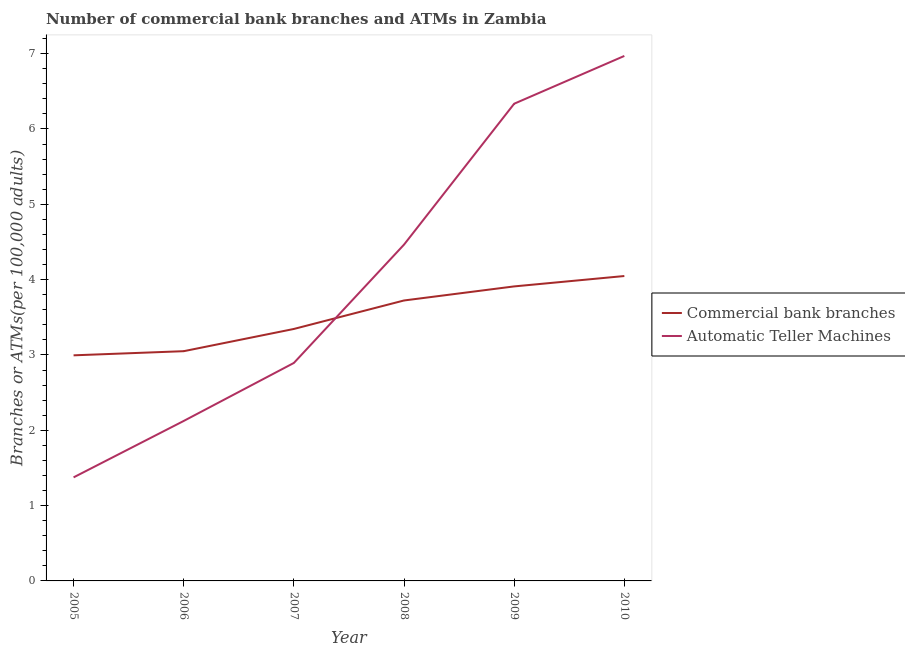Does the line corresponding to number of atms intersect with the line corresponding to number of commercal bank branches?
Keep it short and to the point. Yes. Is the number of lines equal to the number of legend labels?
Provide a succinct answer. Yes. What is the number of commercal bank branches in 2009?
Your response must be concise. 3.91. Across all years, what is the maximum number of commercal bank branches?
Offer a very short reply. 4.05. Across all years, what is the minimum number of atms?
Provide a short and direct response. 1.37. What is the total number of atms in the graph?
Your response must be concise. 24.16. What is the difference between the number of atms in 2005 and that in 2007?
Make the answer very short. -1.52. What is the difference between the number of commercal bank branches in 2007 and the number of atms in 2008?
Offer a very short reply. -1.12. What is the average number of atms per year?
Offer a very short reply. 4.03. In the year 2006, what is the difference between the number of commercal bank branches and number of atms?
Your response must be concise. 0.93. In how many years, is the number of atms greater than 2.2?
Provide a short and direct response. 4. What is the ratio of the number of atms in 2007 to that in 2010?
Keep it short and to the point. 0.42. What is the difference between the highest and the second highest number of commercal bank branches?
Your response must be concise. 0.14. What is the difference between the highest and the lowest number of atms?
Give a very brief answer. 5.59. Is the number of atms strictly less than the number of commercal bank branches over the years?
Offer a very short reply. No. How many years are there in the graph?
Your answer should be compact. 6. What is the difference between two consecutive major ticks on the Y-axis?
Provide a short and direct response. 1. Are the values on the major ticks of Y-axis written in scientific E-notation?
Make the answer very short. No. Does the graph contain any zero values?
Ensure brevity in your answer.  No. Does the graph contain grids?
Ensure brevity in your answer.  No. Where does the legend appear in the graph?
Make the answer very short. Center right. What is the title of the graph?
Offer a very short reply. Number of commercial bank branches and ATMs in Zambia. What is the label or title of the Y-axis?
Keep it short and to the point. Branches or ATMs(per 100,0 adults). What is the Branches or ATMs(per 100,000 adults) of Commercial bank branches in 2005?
Provide a succinct answer. 2.99. What is the Branches or ATMs(per 100,000 adults) of Automatic Teller Machines in 2005?
Your answer should be compact. 1.37. What is the Branches or ATMs(per 100,000 adults) in Commercial bank branches in 2006?
Provide a succinct answer. 3.05. What is the Branches or ATMs(per 100,000 adults) of Automatic Teller Machines in 2006?
Your answer should be very brief. 2.12. What is the Branches or ATMs(per 100,000 adults) of Commercial bank branches in 2007?
Provide a short and direct response. 3.34. What is the Branches or ATMs(per 100,000 adults) in Automatic Teller Machines in 2007?
Keep it short and to the point. 2.89. What is the Branches or ATMs(per 100,000 adults) of Commercial bank branches in 2008?
Provide a succinct answer. 3.72. What is the Branches or ATMs(per 100,000 adults) in Automatic Teller Machines in 2008?
Provide a short and direct response. 4.46. What is the Branches or ATMs(per 100,000 adults) of Commercial bank branches in 2009?
Your answer should be compact. 3.91. What is the Branches or ATMs(per 100,000 adults) of Automatic Teller Machines in 2009?
Provide a succinct answer. 6.33. What is the Branches or ATMs(per 100,000 adults) in Commercial bank branches in 2010?
Your response must be concise. 4.05. What is the Branches or ATMs(per 100,000 adults) in Automatic Teller Machines in 2010?
Your answer should be compact. 6.97. Across all years, what is the maximum Branches or ATMs(per 100,000 adults) of Commercial bank branches?
Your answer should be very brief. 4.05. Across all years, what is the maximum Branches or ATMs(per 100,000 adults) in Automatic Teller Machines?
Give a very brief answer. 6.97. Across all years, what is the minimum Branches or ATMs(per 100,000 adults) of Commercial bank branches?
Provide a succinct answer. 2.99. Across all years, what is the minimum Branches or ATMs(per 100,000 adults) of Automatic Teller Machines?
Provide a short and direct response. 1.37. What is the total Branches or ATMs(per 100,000 adults) in Commercial bank branches in the graph?
Make the answer very short. 21.07. What is the total Branches or ATMs(per 100,000 adults) of Automatic Teller Machines in the graph?
Your response must be concise. 24.16. What is the difference between the Branches or ATMs(per 100,000 adults) in Commercial bank branches in 2005 and that in 2006?
Provide a succinct answer. -0.06. What is the difference between the Branches or ATMs(per 100,000 adults) of Automatic Teller Machines in 2005 and that in 2006?
Your response must be concise. -0.75. What is the difference between the Branches or ATMs(per 100,000 adults) of Commercial bank branches in 2005 and that in 2007?
Make the answer very short. -0.35. What is the difference between the Branches or ATMs(per 100,000 adults) in Automatic Teller Machines in 2005 and that in 2007?
Provide a short and direct response. -1.52. What is the difference between the Branches or ATMs(per 100,000 adults) of Commercial bank branches in 2005 and that in 2008?
Offer a very short reply. -0.73. What is the difference between the Branches or ATMs(per 100,000 adults) of Automatic Teller Machines in 2005 and that in 2008?
Keep it short and to the point. -3.09. What is the difference between the Branches or ATMs(per 100,000 adults) of Commercial bank branches in 2005 and that in 2009?
Keep it short and to the point. -0.92. What is the difference between the Branches or ATMs(per 100,000 adults) in Automatic Teller Machines in 2005 and that in 2009?
Offer a very short reply. -4.96. What is the difference between the Branches or ATMs(per 100,000 adults) in Commercial bank branches in 2005 and that in 2010?
Keep it short and to the point. -1.05. What is the difference between the Branches or ATMs(per 100,000 adults) of Automatic Teller Machines in 2005 and that in 2010?
Provide a succinct answer. -5.59. What is the difference between the Branches or ATMs(per 100,000 adults) in Commercial bank branches in 2006 and that in 2007?
Your answer should be compact. -0.3. What is the difference between the Branches or ATMs(per 100,000 adults) in Automatic Teller Machines in 2006 and that in 2007?
Your answer should be very brief. -0.77. What is the difference between the Branches or ATMs(per 100,000 adults) in Commercial bank branches in 2006 and that in 2008?
Make the answer very short. -0.67. What is the difference between the Branches or ATMs(per 100,000 adults) in Automatic Teller Machines in 2006 and that in 2008?
Your answer should be compact. -2.34. What is the difference between the Branches or ATMs(per 100,000 adults) of Commercial bank branches in 2006 and that in 2009?
Offer a very short reply. -0.86. What is the difference between the Branches or ATMs(per 100,000 adults) in Automatic Teller Machines in 2006 and that in 2009?
Your answer should be very brief. -4.21. What is the difference between the Branches or ATMs(per 100,000 adults) of Commercial bank branches in 2006 and that in 2010?
Offer a terse response. -1. What is the difference between the Branches or ATMs(per 100,000 adults) of Automatic Teller Machines in 2006 and that in 2010?
Your response must be concise. -4.85. What is the difference between the Branches or ATMs(per 100,000 adults) of Commercial bank branches in 2007 and that in 2008?
Ensure brevity in your answer.  -0.38. What is the difference between the Branches or ATMs(per 100,000 adults) of Automatic Teller Machines in 2007 and that in 2008?
Offer a very short reply. -1.57. What is the difference between the Branches or ATMs(per 100,000 adults) in Commercial bank branches in 2007 and that in 2009?
Make the answer very short. -0.56. What is the difference between the Branches or ATMs(per 100,000 adults) of Automatic Teller Machines in 2007 and that in 2009?
Your answer should be very brief. -3.44. What is the difference between the Branches or ATMs(per 100,000 adults) of Commercial bank branches in 2007 and that in 2010?
Offer a terse response. -0.7. What is the difference between the Branches or ATMs(per 100,000 adults) of Automatic Teller Machines in 2007 and that in 2010?
Your answer should be very brief. -4.08. What is the difference between the Branches or ATMs(per 100,000 adults) in Commercial bank branches in 2008 and that in 2009?
Provide a succinct answer. -0.19. What is the difference between the Branches or ATMs(per 100,000 adults) in Automatic Teller Machines in 2008 and that in 2009?
Give a very brief answer. -1.87. What is the difference between the Branches or ATMs(per 100,000 adults) of Commercial bank branches in 2008 and that in 2010?
Provide a succinct answer. -0.32. What is the difference between the Branches or ATMs(per 100,000 adults) of Automatic Teller Machines in 2008 and that in 2010?
Give a very brief answer. -2.5. What is the difference between the Branches or ATMs(per 100,000 adults) of Commercial bank branches in 2009 and that in 2010?
Make the answer very short. -0.14. What is the difference between the Branches or ATMs(per 100,000 adults) of Automatic Teller Machines in 2009 and that in 2010?
Keep it short and to the point. -0.63. What is the difference between the Branches or ATMs(per 100,000 adults) in Commercial bank branches in 2005 and the Branches or ATMs(per 100,000 adults) in Automatic Teller Machines in 2006?
Offer a terse response. 0.87. What is the difference between the Branches or ATMs(per 100,000 adults) of Commercial bank branches in 2005 and the Branches or ATMs(per 100,000 adults) of Automatic Teller Machines in 2007?
Your answer should be very brief. 0.1. What is the difference between the Branches or ATMs(per 100,000 adults) in Commercial bank branches in 2005 and the Branches or ATMs(per 100,000 adults) in Automatic Teller Machines in 2008?
Your answer should be very brief. -1.47. What is the difference between the Branches or ATMs(per 100,000 adults) of Commercial bank branches in 2005 and the Branches or ATMs(per 100,000 adults) of Automatic Teller Machines in 2009?
Provide a short and direct response. -3.34. What is the difference between the Branches or ATMs(per 100,000 adults) of Commercial bank branches in 2005 and the Branches or ATMs(per 100,000 adults) of Automatic Teller Machines in 2010?
Provide a succinct answer. -3.97. What is the difference between the Branches or ATMs(per 100,000 adults) in Commercial bank branches in 2006 and the Branches or ATMs(per 100,000 adults) in Automatic Teller Machines in 2007?
Ensure brevity in your answer.  0.16. What is the difference between the Branches or ATMs(per 100,000 adults) in Commercial bank branches in 2006 and the Branches or ATMs(per 100,000 adults) in Automatic Teller Machines in 2008?
Your answer should be very brief. -1.41. What is the difference between the Branches or ATMs(per 100,000 adults) of Commercial bank branches in 2006 and the Branches or ATMs(per 100,000 adults) of Automatic Teller Machines in 2009?
Provide a short and direct response. -3.29. What is the difference between the Branches or ATMs(per 100,000 adults) of Commercial bank branches in 2006 and the Branches or ATMs(per 100,000 adults) of Automatic Teller Machines in 2010?
Your response must be concise. -3.92. What is the difference between the Branches or ATMs(per 100,000 adults) of Commercial bank branches in 2007 and the Branches or ATMs(per 100,000 adults) of Automatic Teller Machines in 2008?
Provide a short and direct response. -1.12. What is the difference between the Branches or ATMs(per 100,000 adults) in Commercial bank branches in 2007 and the Branches or ATMs(per 100,000 adults) in Automatic Teller Machines in 2009?
Your answer should be very brief. -2.99. What is the difference between the Branches or ATMs(per 100,000 adults) in Commercial bank branches in 2007 and the Branches or ATMs(per 100,000 adults) in Automatic Teller Machines in 2010?
Your response must be concise. -3.62. What is the difference between the Branches or ATMs(per 100,000 adults) in Commercial bank branches in 2008 and the Branches or ATMs(per 100,000 adults) in Automatic Teller Machines in 2009?
Provide a succinct answer. -2.61. What is the difference between the Branches or ATMs(per 100,000 adults) in Commercial bank branches in 2008 and the Branches or ATMs(per 100,000 adults) in Automatic Teller Machines in 2010?
Provide a short and direct response. -3.25. What is the difference between the Branches or ATMs(per 100,000 adults) in Commercial bank branches in 2009 and the Branches or ATMs(per 100,000 adults) in Automatic Teller Machines in 2010?
Your answer should be compact. -3.06. What is the average Branches or ATMs(per 100,000 adults) in Commercial bank branches per year?
Provide a succinct answer. 3.51. What is the average Branches or ATMs(per 100,000 adults) of Automatic Teller Machines per year?
Make the answer very short. 4.03. In the year 2005, what is the difference between the Branches or ATMs(per 100,000 adults) of Commercial bank branches and Branches or ATMs(per 100,000 adults) of Automatic Teller Machines?
Offer a very short reply. 1.62. In the year 2006, what is the difference between the Branches or ATMs(per 100,000 adults) in Commercial bank branches and Branches or ATMs(per 100,000 adults) in Automatic Teller Machines?
Make the answer very short. 0.93. In the year 2007, what is the difference between the Branches or ATMs(per 100,000 adults) in Commercial bank branches and Branches or ATMs(per 100,000 adults) in Automatic Teller Machines?
Ensure brevity in your answer.  0.45. In the year 2008, what is the difference between the Branches or ATMs(per 100,000 adults) of Commercial bank branches and Branches or ATMs(per 100,000 adults) of Automatic Teller Machines?
Offer a very short reply. -0.74. In the year 2009, what is the difference between the Branches or ATMs(per 100,000 adults) in Commercial bank branches and Branches or ATMs(per 100,000 adults) in Automatic Teller Machines?
Your answer should be compact. -2.43. In the year 2010, what is the difference between the Branches or ATMs(per 100,000 adults) of Commercial bank branches and Branches or ATMs(per 100,000 adults) of Automatic Teller Machines?
Ensure brevity in your answer.  -2.92. What is the ratio of the Branches or ATMs(per 100,000 adults) of Commercial bank branches in 2005 to that in 2006?
Your answer should be compact. 0.98. What is the ratio of the Branches or ATMs(per 100,000 adults) of Automatic Teller Machines in 2005 to that in 2006?
Provide a short and direct response. 0.65. What is the ratio of the Branches or ATMs(per 100,000 adults) in Commercial bank branches in 2005 to that in 2007?
Your response must be concise. 0.9. What is the ratio of the Branches or ATMs(per 100,000 adults) of Automatic Teller Machines in 2005 to that in 2007?
Keep it short and to the point. 0.47. What is the ratio of the Branches or ATMs(per 100,000 adults) in Commercial bank branches in 2005 to that in 2008?
Your answer should be compact. 0.8. What is the ratio of the Branches or ATMs(per 100,000 adults) of Automatic Teller Machines in 2005 to that in 2008?
Make the answer very short. 0.31. What is the ratio of the Branches or ATMs(per 100,000 adults) in Commercial bank branches in 2005 to that in 2009?
Your answer should be very brief. 0.77. What is the ratio of the Branches or ATMs(per 100,000 adults) of Automatic Teller Machines in 2005 to that in 2009?
Ensure brevity in your answer.  0.22. What is the ratio of the Branches or ATMs(per 100,000 adults) of Commercial bank branches in 2005 to that in 2010?
Your answer should be compact. 0.74. What is the ratio of the Branches or ATMs(per 100,000 adults) in Automatic Teller Machines in 2005 to that in 2010?
Provide a short and direct response. 0.2. What is the ratio of the Branches or ATMs(per 100,000 adults) of Commercial bank branches in 2006 to that in 2007?
Provide a succinct answer. 0.91. What is the ratio of the Branches or ATMs(per 100,000 adults) of Automatic Teller Machines in 2006 to that in 2007?
Provide a succinct answer. 0.73. What is the ratio of the Branches or ATMs(per 100,000 adults) of Commercial bank branches in 2006 to that in 2008?
Your answer should be compact. 0.82. What is the ratio of the Branches or ATMs(per 100,000 adults) in Automatic Teller Machines in 2006 to that in 2008?
Your response must be concise. 0.48. What is the ratio of the Branches or ATMs(per 100,000 adults) in Commercial bank branches in 2006 to that in 2009?
Offer a very short reply. 0.78. What is the ratio of the Branches or ATMs(per 100,000 adults) of Automatic Teller Machines in 2006 to that in 2009?
Ensure brevity in your answer.  0.34. What is the ratio of the Branches or ATMs(per 100,000 adults) of Commercial bank branches in 2006 to that in 2010?
Ensure brevity in your answer.  0.75. What is the ratio of the Branches or ATMs(per 100,000 adults) of Automatic Teller Machines in 2006 to that in 2010?
Your answer should be compact. 0.3. What is the ratio of the Branches or ATMs(per 100,000 adults) in Commercial bank branches in 2007 to that in 2008?
Provide a short and direct response. 0.9. What is the ratio of the Branches or ATMs(per 100,000 adults) of Automatic Teller Machines in 2007 to that in 2008?
Provide a succinct answer. 0.65. What is the ratio of the Branches or ATMs(per 100,000 adults) of Commercial bank branches in 2007 to that in 2009?
Your answer should be compact. 0.86. What is the ratio of the Branches or ATMs(per 100,000 adults) in Automatic Teller Machines in 2007 to that in 2009?
Make the answer very short. 0.46. What is the ratio of the Branches or ATMs(per 100,000 adults) in Commercial bank branches in 2007 to that in 2010?
Keep it short and to the point. 0.83. What is the ratio of the Branches or ATMs(per 100,000 adults) in Automatic Teller Machines in 2007 to that in 2010?
Ensure brevity in your answer.  0.42. What is the ratio of the Branches or ATMs(per 100,000 adults) in Commercial bank branches in 2008 to that in 2009?
Make the answer very short. 0.95. What is the ratio of the Branches or ATMs(per 100,000 adults) in Automatic Teller Machines in 2008 to that in 2009?
Provide a short and direct response. 0.7. What is the ratio of the Branches or ATMs(per 100,000 adults) of Commercial bank branches in 2008 to that in 2010?
Keep it short and to the point. 0.92. What is the ratio of the Branches or ATMs(per 100,000 adults) in Automatic Teller Machines in 2008 to that in 2010?
Provide a short and direct response. 0.64. What is the ratio of the Branches or ATMs(per 100,000 adults) of Commercial bank branches in 2009 to that in 2010?
Keep it short and to the point. 0.97. What is the ratio of the Branches or ATMs(per 100,000 adults) in Automatic Teller Machines in 2009 to that in 2010?
Ensure brevity in your answer.  0.91. What is the difference between the highest and the second highest Branches or ATMs(per 100,000 adults) of Commercial bank branches?
Keep it short and to the point. 0.14. What is the difference between the highest and the second highest Branches or ATMs(per 100,000 adults) of Automatic Teller Machines?
Offer a very short reply. 0.63. What is the difference between the highest and the lowest Branches or ATMs(per 100,000 adults) in Commercial bank branches?
Your response must be concise. 1.05. What is the difference between the highest and the lowest Branches or ATMs(per 100,000 adults) of Automatic Teller Machines?
Keep it short and to the point. 5.59. 